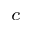Convert formula to latex. <formula><loc_0><loc_0><loc_500><loc_500>_ { c }</formula> 